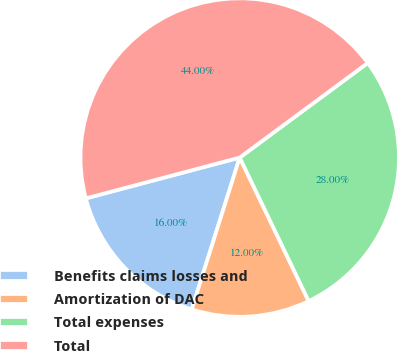Convert chart. <chart><loc_0><loc_0><loc_500><loc_500><pie_chart><fcel>Benefits claims losses and<fcel>Amortization of DAC<fcel>Total expenses<fcel>Total<nl><fcel>16.0%<fcel>12.0%<fcel>28.0%<fcel>44.0%<nl></chart> 